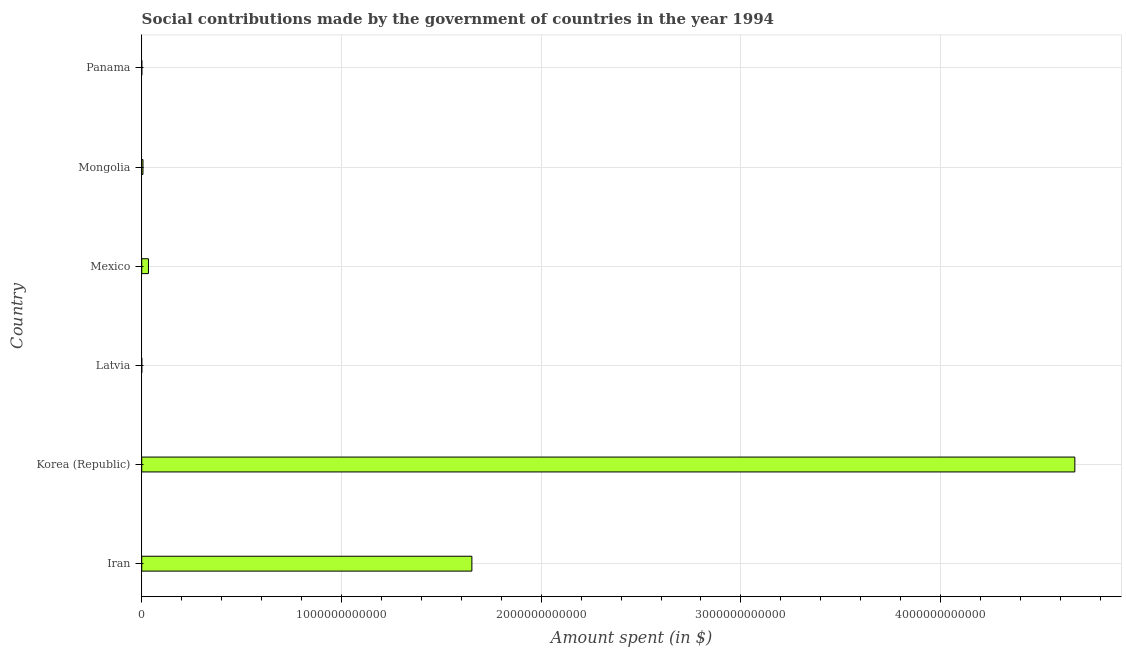Does the graph contain any zero values?
Ensure brevity in your answer.  No. What is the title of the graph?
Provide a short and direct response. Social contributions made by the government of countries in the year 1994. What is the label or title of the X-axis?
Give a very brief answer. Amount spent (in $). What is the amount spent in making social contributions in Latvia?
Your response must be concise. 1.81e+08. Across all countries, what is the maximum amount spent in making social contributions?
Offer a terse response. 4.67e+12. Across all countries, what is the minimum amount spent in making social contributions?
Your response must be concise. 1.81e+08. In which country was the amount spent in making social contributions minimum?
Offer a very short reply. Latvia. What is the sum of the amount spent in making social contributions?
Provide a short and direct response. 6.37e+12. What is the difference between the amount spent in making social contributions in Latvia and Mongolia?
Your response must be concise. -6.03e+09. What is the average amount spent in making social contributions per country?
Provide a short and direct response. 1.06e+12. What is the median amount spent in making social contributions?
Your answer should be compact. 2.00e+1. What is the ratio of the amount spent in making social contributions in Iran to that in Panama?
Make the answer very short. 3864.86. Is the amount spent in making social contributions in Korea (Republic) less than that in Panama?
Offer a very short reply. No. What is the difference between the highest and the second highest amount spent in making social contributions?
Your answer should be very brief. 3.02e+12. What is the difference between the highest and the lowest amount spent in making social contributions?
Your response must be concise. 4.67e+12. In how many countries, is the amount spent in making social contributions greater than the average amount spent in making social contributions taken over all countries?
Your answer should be compact. 2. How many bars are there?
Keep it short and to the point. 6. What is the difference between two consecutive major ticks on the X-axis?
Provide a short and direct response. 1.00e+12. Are the values on the major ticks of X-axis written in scientific E-notation?
Make the answer very short. No. What is the Amount spent (in $) of Iran?
Your answer should be very brief. 1.65e+12. What is the Amount spent (in $) in Korea (Republic)?
Ensure brevity in your answer.  4.67e+12. What is the Amount spent (in $) of Latvia?
Offer a terse response. 1.81e+08. What is the Amount spent (in $) of Mexico?
Your response must be concise. 3.37e+1. What is the Amount spent (in $) in Mongolia?
Your response must be concise. 6.21e+09. What is the Amount spent (in $) in Panama?
Give a very brief answer. 4.28e+08. What is the difference between the Amount spent (in $) in Iran and Korea (Republic)?
Ensure brevity in your answer.  -3.02e+12. What is the difference between the Amount spent (in $) in Iran and Latvia?
Provide a succinct answer. 1.65e+12. What is the difference between the Amount spent (in $) in Iran and Mexico?
Your answer should be very brief. 1.62e+12. What is the difference between the Amount spent (in $) in Iran and Mongolia?
Ensure brevity in your answer.  1.65e+12. What is the difference between the Amount spent (in $) in Iran and Panama?
Provide a short and direct response. 1.65e+12. What is the difference between the Amount spent (in $) in Korea (Republic) and Latvia?
Offer a very short reply. 4.67e+12. What is the difference between the Amount spent (in $) in Korea (Republic) and Mexico?
Offer a terse response. 4.64e+12. What is the difference between the Amount spent (in $) in Korea (Republic) and Mongolia?
Provide a short and direct response. 4.67e+12. What is the difference between the Amount spent (in $) in Korea (Republic) and Panama?
Make the answer very short. 4.67e+12. What is the difference between the Amount spent (in $) in Latvia and Mexico?
Make the answer very short. -3.35e+1. What is the difference between the Amount spent (in $) in Latvia and Mongolia?
Your answer should be compact. -6.03e+09. What is the difference between the Amount spent (in $) in Latvia and Panama?
Your answer should be very brief. -2.47e+08. What is the difference between the Amount spent (in $) in Mexico and Mongolia?
Provide a succinct answer. 2.75e+1. What is the difference between the Amount spent (in $) in Mexico and Panama?
Offer a very short reply. 3.33e+1. What is the difference between the Amount spent (in $) in Mongolia and Panama?
Give a very brief answer. 5.78e+09. What is the ratio of the Amount spent (in $) in Iran to that in Korea (Republic)?
Make the answer very short. 0.35. What is the ratio of the Amount spent (in $) in Iran to that in Latvia?
Your response must be concise. 9152.32. What is the ratio of the Amount spent (in $) in Iran to that in Mexico?
Your response must be concise. 49.01. What is the ratio of the Amount spent (in $) in Iran to that in Mongolia?
Your answer should be very brief. 266.1. What is the ratio of the Amount spent (in $) in Iran to that in Panama?
Keep it short and to the point. 3864.86. What is the ratio of the Amount spent (in $) in Korea (Republic) to that in Latvia?
Give a very brief answer. 2.59e+04. What is the ratio of the Amount spent (in $) in Korea (Republic) to that in Mexico?
Make the answer very short. 138.52. What is the ratio of the Amount spent (in $) in Korea (Republic) to that in Mongolia?
Provide a succinct answer. 752.09. What is the ratio of the Amount spent (in $) in Korea (Republic) to that in Panama?
Ensure brevity in your answer.  1.09e+04. What is the ratio of the Amount spent (in $) in Latvia to that in Mexico?
Provide a succinct answer. 0.01. What is the ratio of the Amount spent (in $) in Latvia to that in Mongolia?
Make the answer very short. 0.03. What is the ratio of the Amount spent (in $) in Latvia to that in Panama?
Offer a very short reply. 0.42. What is the ratio of the Amount spent (in $) in Mexico to that in Mongolia?
Offer a terse response. 5.43. What is the ratio of the Amount spent (in $) in Mexico to that in Panama?
Offer a terse response. 78.86. What is the ratio of the Amount spent (in $) in Mongolia to that in Panama?
Your response must be concise. 14.52. 